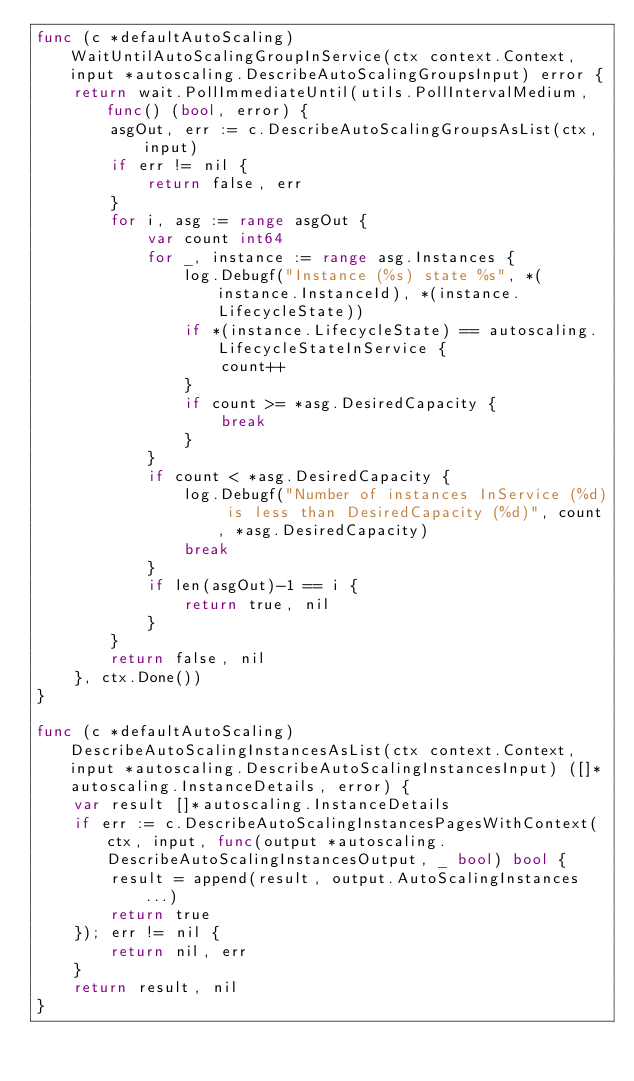<code> <loc_0><loc_0><loc_500><loc_500><_Go_>func (c *defaultAutoScaling) WaitUntilAutoScalingGroupInService(ctx context.Context, input *autoscaling.DescribeAutoScalingGroupsInput) error {
	return wait.PollImmediateUntil(utils.PollIntervalMedium, func() (bool, error) {
		asgOut, err := c.DescribeAutoScalingGroupsAsList(ctx, input)
		if err != nil {
			return false, err
		}
		for i, asg := range asgOut {
			var count int64
			for _, instance := range asg.Instances {
				log.Debugf("Instance (%s) state %s", *(instance.InstanceId), *(instance.LifecycleState))
				if *(instance.LifecycleState) == autoscaling.LifecycleStateInService {
					count++
				}
				if count >= *asg.DesiredCapacity {
					break
				}
			}
			if count < *asg.DesiredCapacity {
				log.Debugf("Number of instances InService (%d) is less than DesiredCapacity (%d)", count, *asg.DesiredCapacity)
				break
			}
			if len(asgOut)-1 == i {
				return true, nil
			}
		}
		return false, nil
	}, ctx.Done())
}

func (c *defaultAutoScaling) DescribeAutoScalingInstancesAsList(ctx context.Context, input *autoscaling.DescribeAutoScalingInstancesInput) ([]*autoscaling.InstanceDetails, error) {
	var result []*autoscaling.InstanceDetails
	if err := c.DescribeAutoScalingInstancesPagesWithContext(ctx, input, func(output *autoscaling.DescribeAutoScalingInstancesOutput, _ bool) bool {
		result = append(result, output.AutoScalingInstances...)
		return true
	}); err != nil {
		return nil, err
	}
	return result, nil
}
</code> 